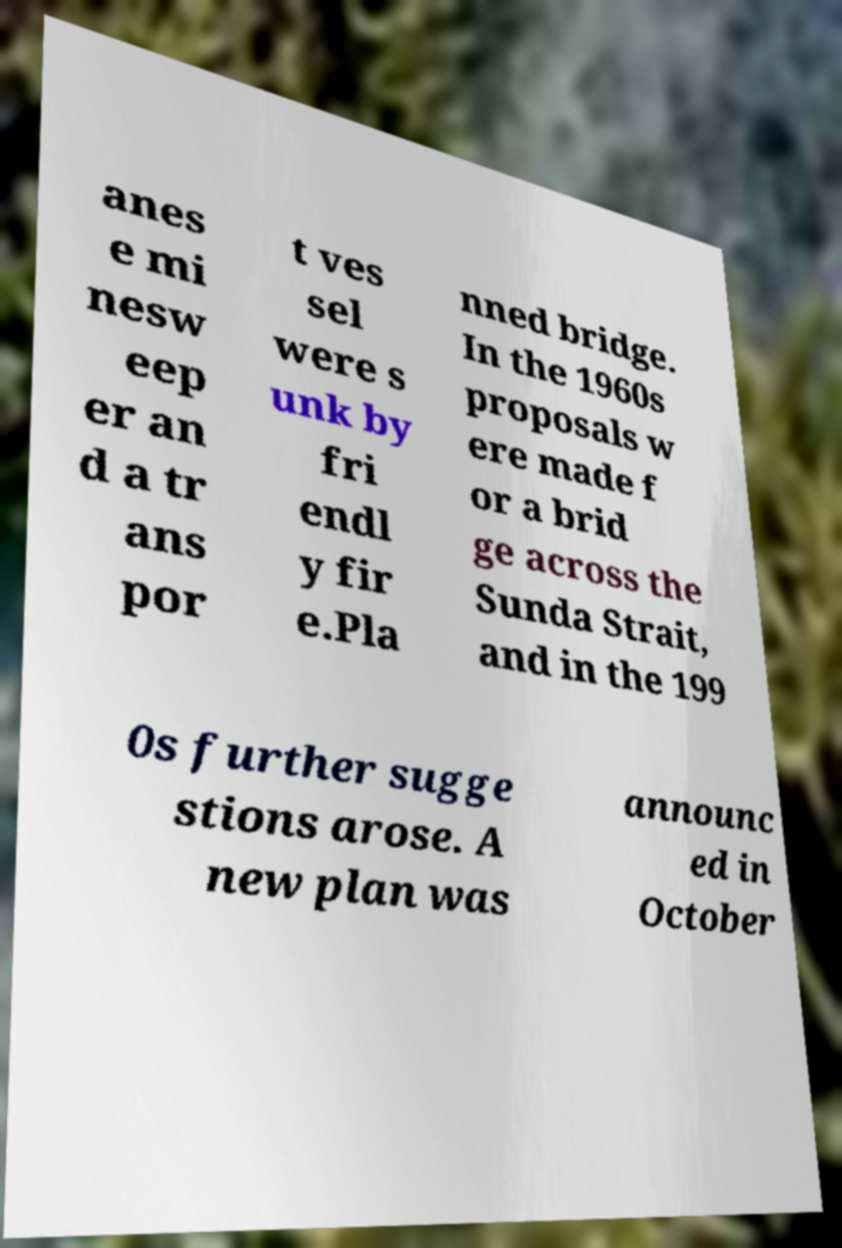Could you extract and type out the text from this image? anes e mi nesw eep er an d a tr ans por t ves sel were s unk by fri endl y fir e.Pla nned bridge. In the 1960s proposals w ere made f or a brid ge across the Sunda Strait, and in the 199 0s further sugge stions arose. A new plan was announc ed in October 